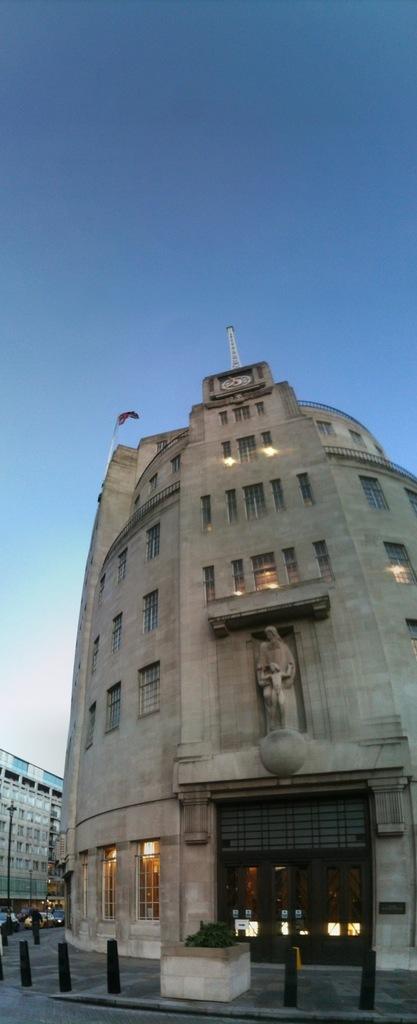Describe this image in one or two sentences. This is an outside view. At the bottom of the image I can see the road and a person is working on the footpath and also I can see few vehicles. In a background there are two buildings. On the top of the image I can see the sky. 